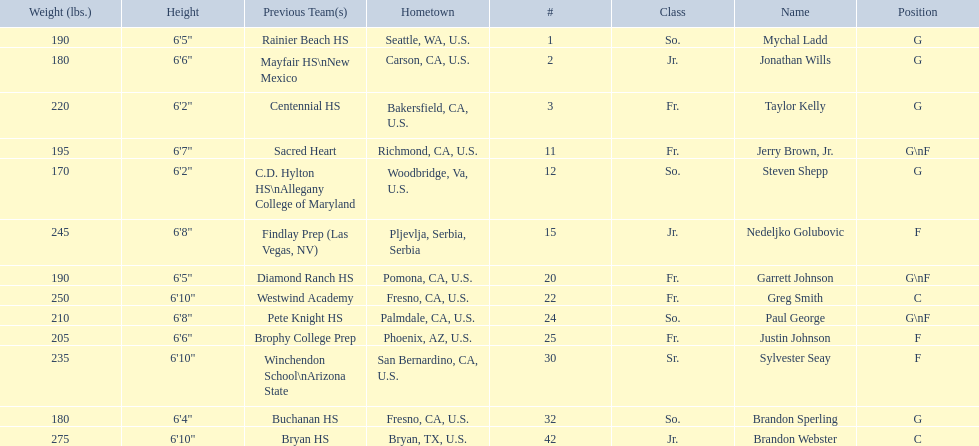What are the names for all players? Mychal Ladd, Jonathan Wills, Taylor Kelly, Jerry Brown, Jr., Steven Shepp, Nedeljko Golubovic, Garrett Johnson, Greg Smith, Paul George, Justin Johnson, Sylvester Seay, Brandon Sperling, Brandon Webster. Which players are taller than 6'8? Nedeljko Golubovic, Greg Smith, Paul George, Sylvester Seay, Brandon Webster. How tall is paul george? 6'8". How tall is greg smith? 6'10". Of these two, which it tallest? Greg Smith. 